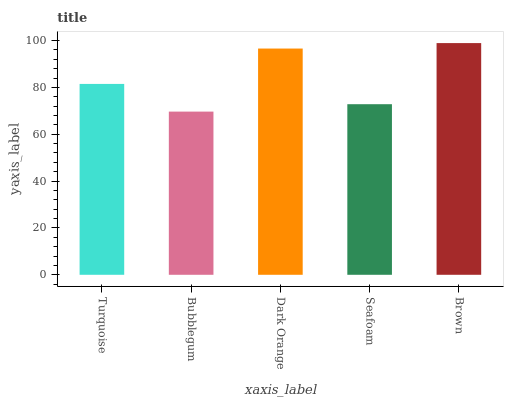Is Bubblegum the minimum?
Answer yes or no. Yes. Is Brown the maximum?
Answer yes or no. Yes. Is Dark Orange the minimum?
Answer yes or no. No. Is Dark Orange the maximum?
Answer yes or no. No. Is Dark Orange greater than Bubblegum?
Answer yes or no. Yes. Is Bubblegum less than Dark Orange?
Answer yes or no. Yes. Is Bubblegum greater than Dark Orange?
Answer yes or no. No. Is Dark Orange less than Bubblegum?
Answer yes or no. No. Is Turquoise the high median?
Answer yes or no. Yes. Is Turquoise the low median?
Answer yes or no. Yes. Is Bubblegum the high median?
Answer yes or no. No. Is Brown the low median?
Answer yes or no. No. 